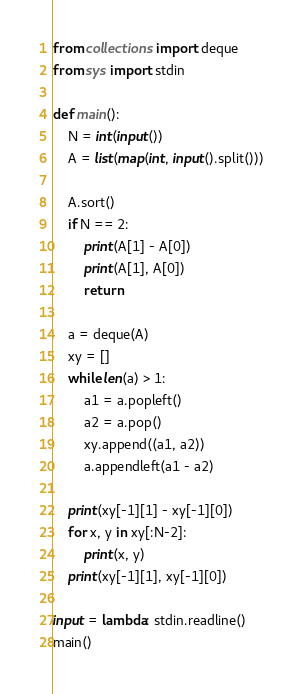Convert code to text. <code><loc_0><loc_0><loc_500><loc_500><_Python_>from collections import deque
from sys import stdin

def main():
    N = int(input())
    A = list(map(int, input().split()))

    A.sort()
    if N == 2:
        print(A[1] - A[0])
        print(A[1], A[0])
        return

    a = deque(A)
    xy = []
    while len(a) > 1:
        a1 = a.popleft()
        a2 = a.pop()
        xy.append((a1, a2))
        a.appendleft(a1 - a2)

    print(xy[-1][1] - xy[-1][0])
    for x, y in xy[:N-2]:
        print(x, y)
    print(xy[-1][1], xy[-1][0])

input = lambda: stdin.readline()
main()
</code> 